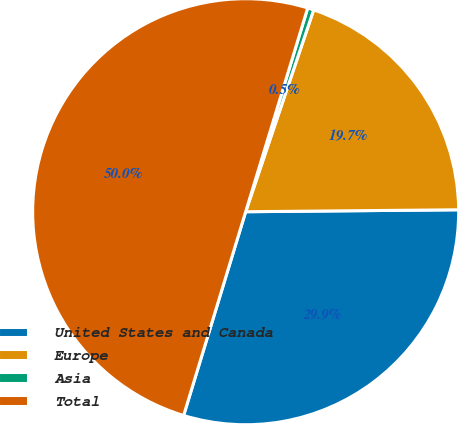<chart> <loc_0><loc_0><loc_500><loc_500><pie_chart><fcel>United States and Canada<fcel>Europe<fcel>Asia<fcel>Total<nl><fcel>29.85%<fcel>19.68%<fcel>0.47%<fcel>50.0%<nl></chart> 